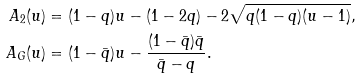Convert formula to latex. <formula><loc_0><loc_0><loc_500><loc_500>A _ { 2 } ( u ) & = ( 1 - q ) u - ( 1 - 2 q ) - 2 \sqrt { q ( 1 - q ) ( u - 1 ) } , \\ A _ { G } ( u ) & = ( 1 - \bar { q } ) u - \frac { ( 1 - \bar { q } ) \bar { q } } { \bar { q } - q } .</formula> 